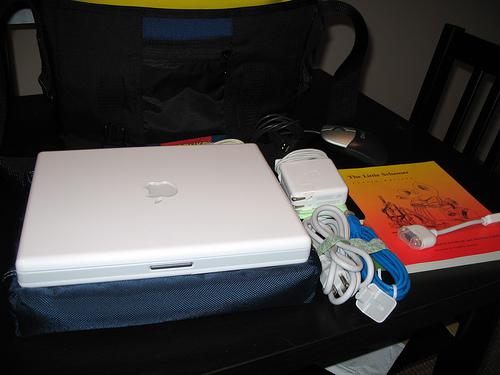Question: who is looking at these item?
Choices:
A. The man.
B. The photographer.
C. The woman.
D. The kid.
Answer with the letter. Answer: B Question: why is the laptop closed?
Choices:
A. To save the battery life.
B. It does not work.
C. It isn't needed, presently.
D. It's about to be put away.
Answer with the letter. Answer: C 